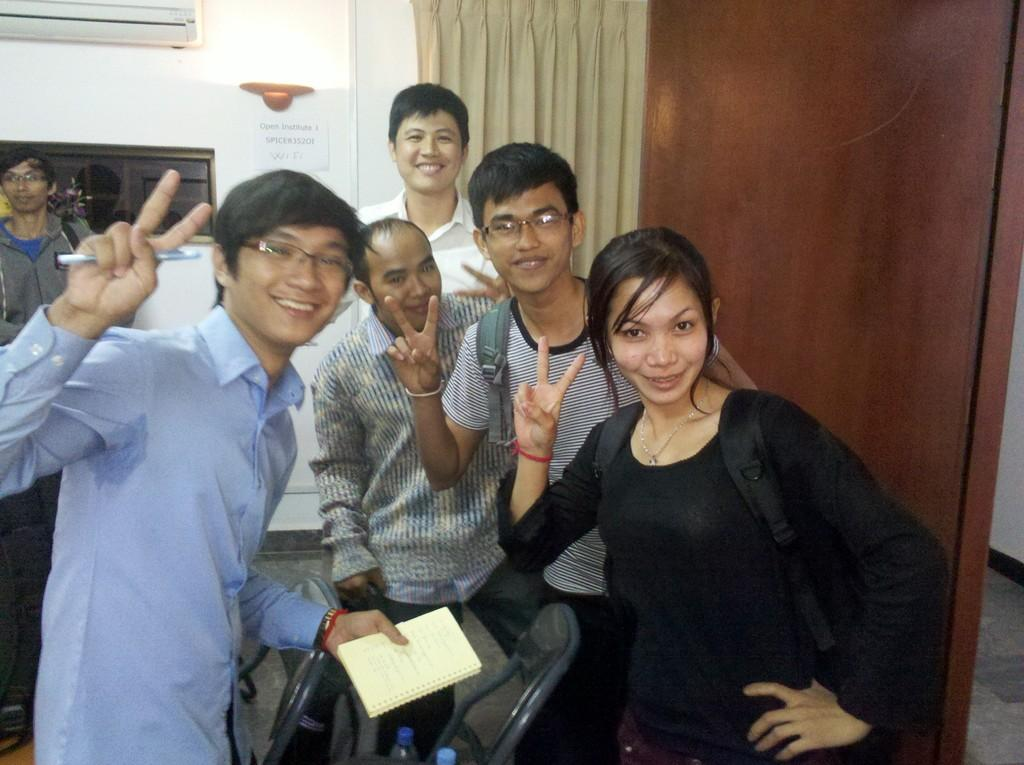How many people are in the image? There are people in the image. What is present in the background of the image? There is a wall in the image. What type of window treatment is visible in the image? There is a curtain in the image. What can be seen on the wall in the image? There is a poster in the image. What is one person in the image holding? A person in the image is holding a book. What is the relation between the person holding the book and the person standing next to them in the image? The provided facts do not give any information about the relationship between the people in the image, so we cannot determine their relation. 